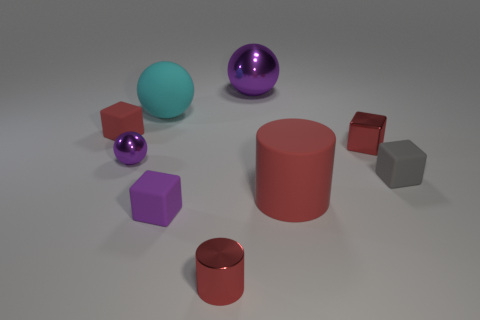What color is the cylinder that is made of the same material as the gray block?
Your response must be concise. Red. How many large cylinders have the same material as the large cyan thing?
Give a very brief answer. 1. Is the color of the tiny cube that is in front of the big red cylinder the same as the tiny cylinder?
Make the answer very short. No. What number of other small red objects are the same shape as the small red matte object?
Keep it short and to the point. 1. Are there an equal number of red blocks left of the small cylinder and matte objects?
Provide a short and direct response. No. What is the color of the ball that is the same size as the red shiny cylinder?
Make the answer very short. Purple. Is there a purple object of the same shape as the tiny red matte object?
Your answer should be compact. Yes. There is a purple sphere in front of the red block in front of the red matte thing left of the metallic cylinder; what is its material?
Your answer should be compact. Metal. What number of other things are there of the same size as the metal cube?
Give a very brief answer. 5. The rubber ball is what color?
Give a very brief answer. Cyan. 